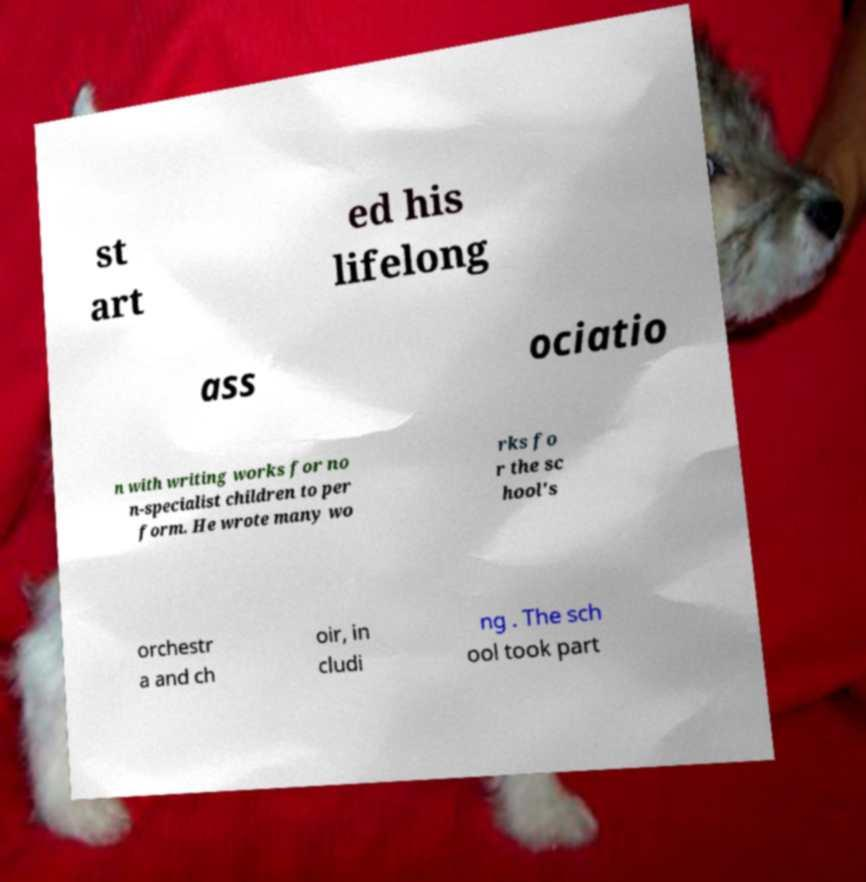Could you assist in decoding the text presented in this image and type it out clearly? st art ed his lifelong ass ociatio n with writing works for no n-specialist children to per form. He wrote many wo rks fo r the sc hool's orchestr a and ch oir, in cludi ng . The sch ool took part 